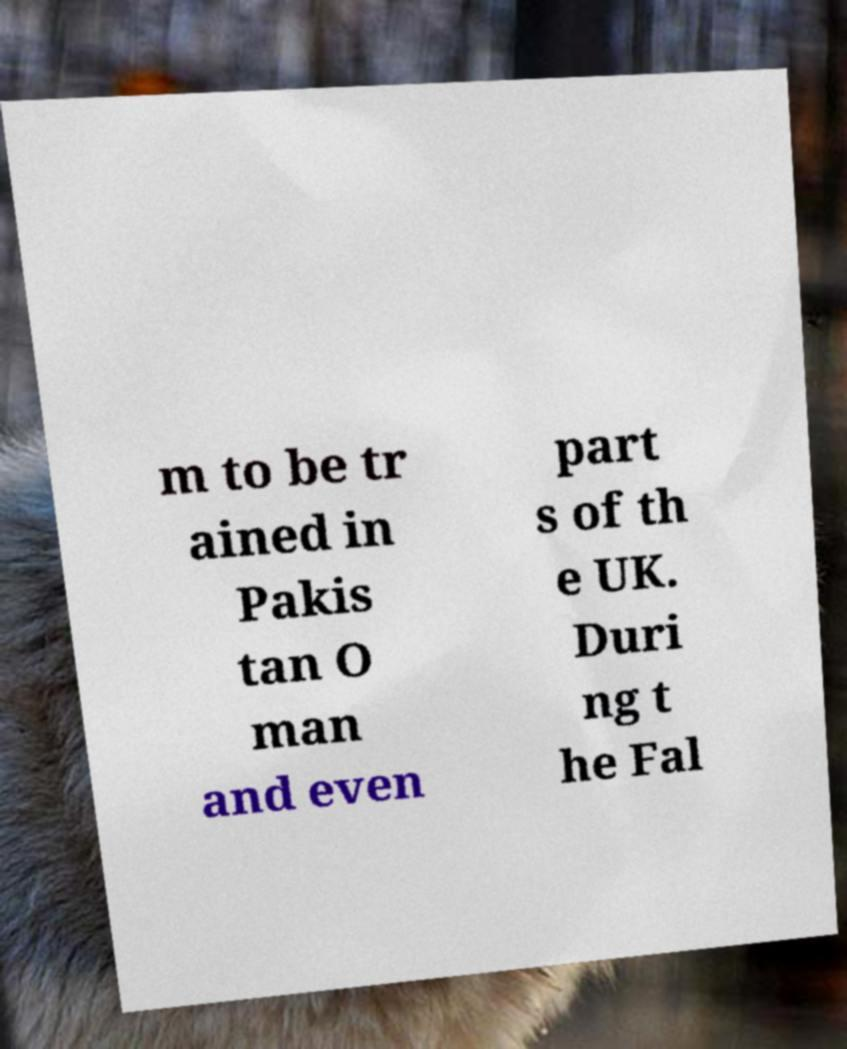For documentation purposes, I need the text within this image transcribed. Could you provide that? m to be tr ained in Pakis tan O man and even part s of th e UK. Duri ng t he Fal 